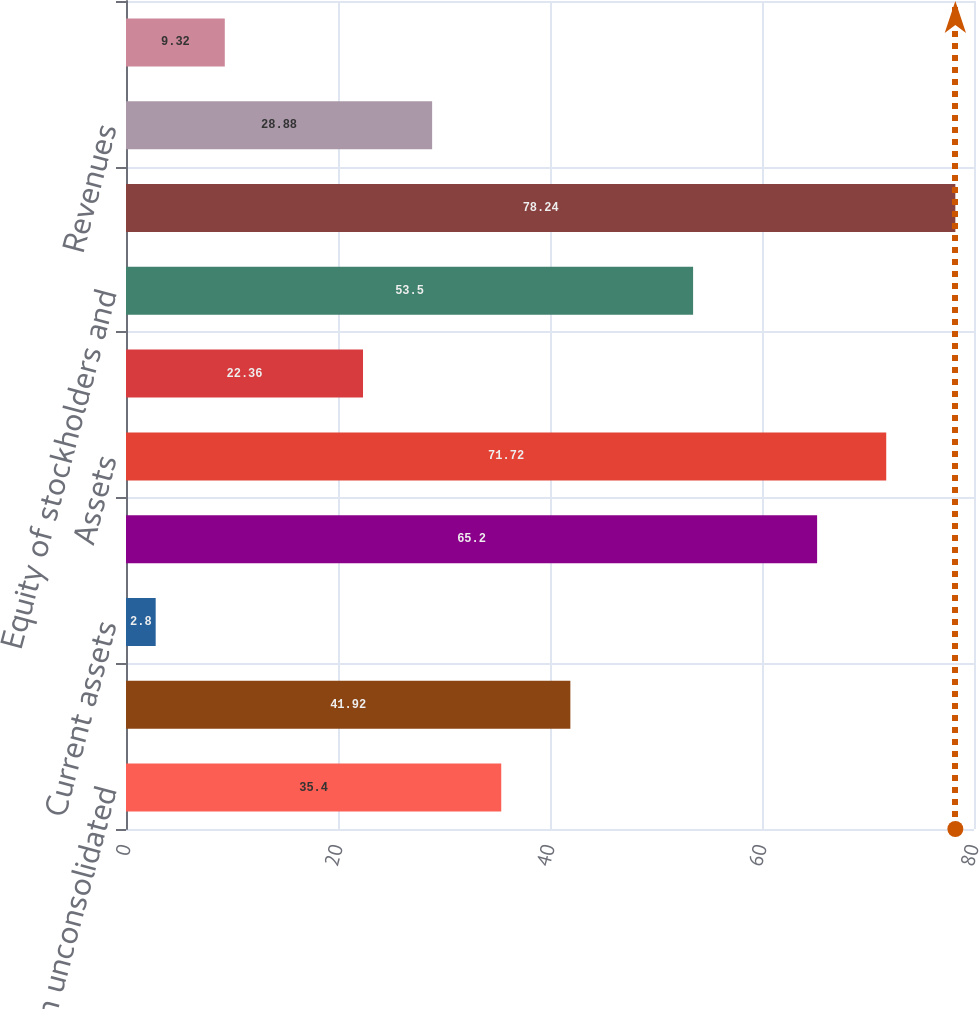Convert chart to OTSL. <chart><loc_0><loc_0><loc_500><loc_500><bar_chart><fcel>Investment in unconsolidated<fcel>Equity in net assets of<fcel>Current assets<fcel>Other assets<fcel>Assets<fcel>Long-term liabilities<fcel>Equity of stockholders and<fcel>Liabilities and equity<fcel>Revenues<fcel>Expenses<nl><fcel>35.4<fcel>41.92<fcel>2.8<fcel>65.2<fcel>71.72<fcel>22.36<fcel>53.5<fcel>78.24<fcel>28.88<fcel>9.32<nl></chart> 